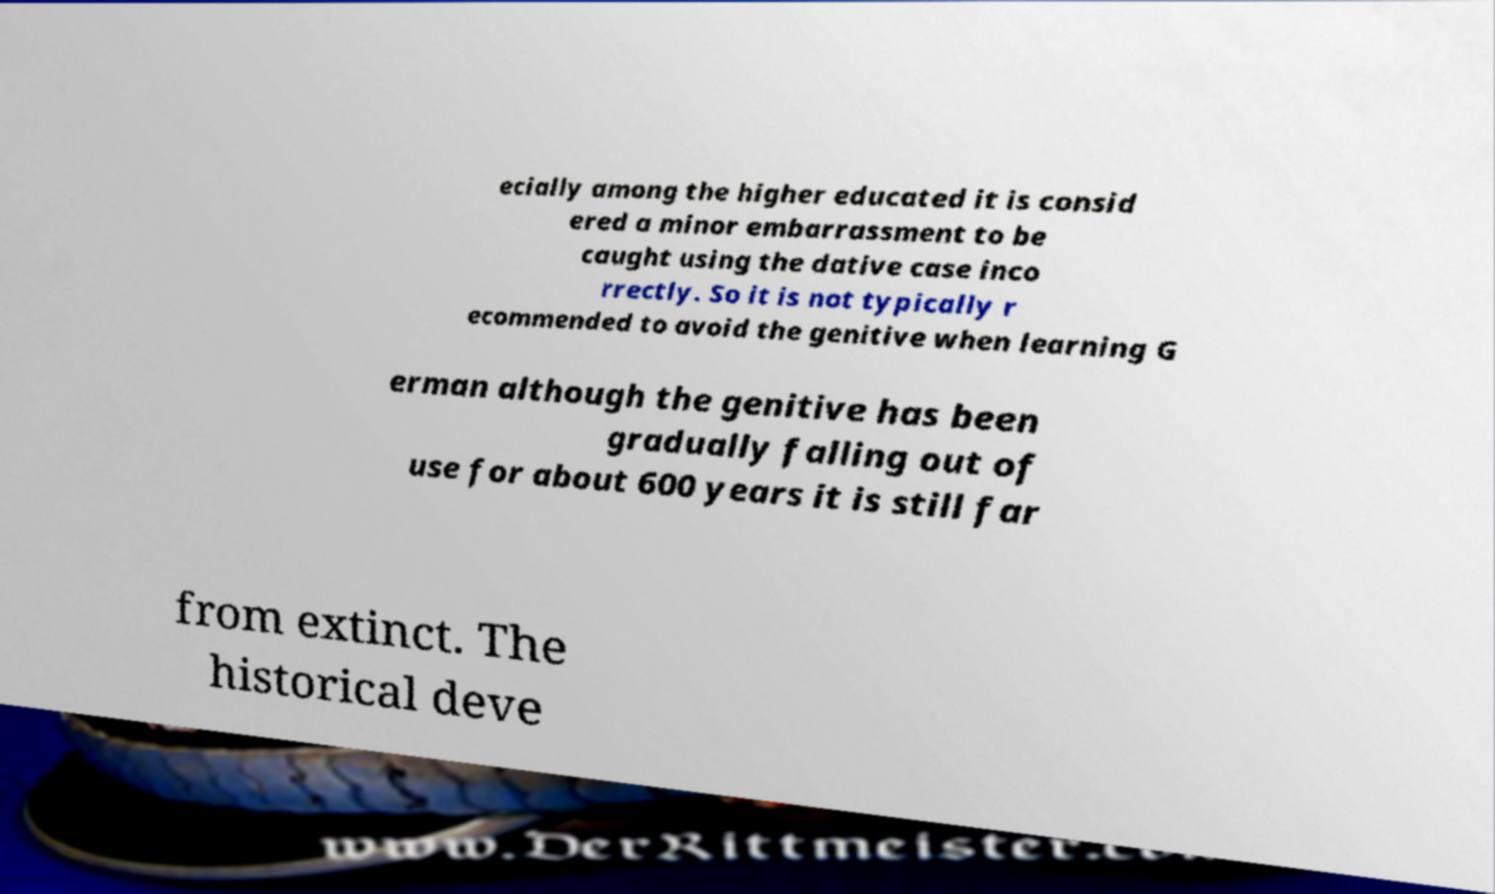Could you assist in decoding the text presented in this image and type it out clearly? ecially among the higher educated it is consid ered a minor embarrassment to be caught using the dative case inco rrectly. So it is not typically r ecommended to avoid the genitive when learning G erman although the genitive has been gradually falling out of use for about 600 years it is still far from extinct. The historical deve 